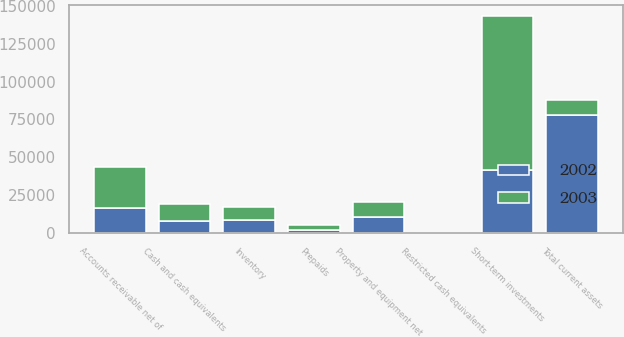<chart> <loc_0><loc_0><loc_500><loc_500><stacked_bar_chart><ecel><fcel>Cash and cash equivalents<fcel>Short-term investments<fcel>Accounts receivable net of<fcel>Inventory<fcel>Prepaids<fcel>Restricted cash equivalents<fcel>Total current assets<fcel>Property and equipment net<nl><fcel>2003<fcel>11335<fcel>101614<fcel>26820<fcel>8788<fcel>3203<fcel>188<fcel>10288<fcel>10288<nl><fcel>2002<fcel>8052<fcel>41832<fcel>16887<fcel>8738<fcel>2151<fcel>173<fcel>77833<fcel>10388<nl></chart> 